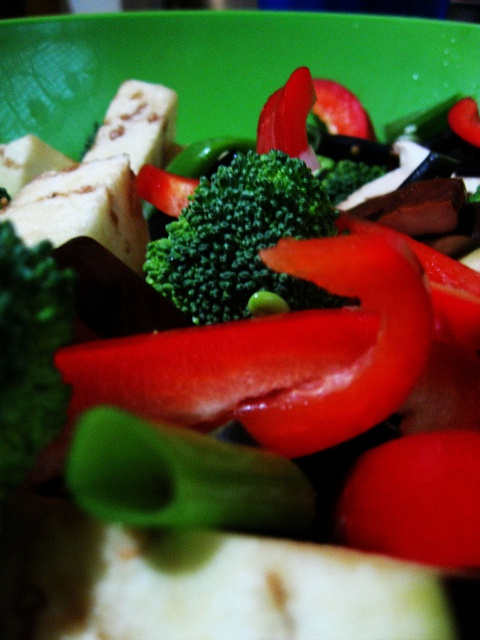Describe the objects in this image and their specific colors. I can see bowl in black, green, and darkgreen tones, broccoli in black, darkgreen, teal, and green tones, and broccoli in black, darkgreen, maroon, and teal tones in this image. 